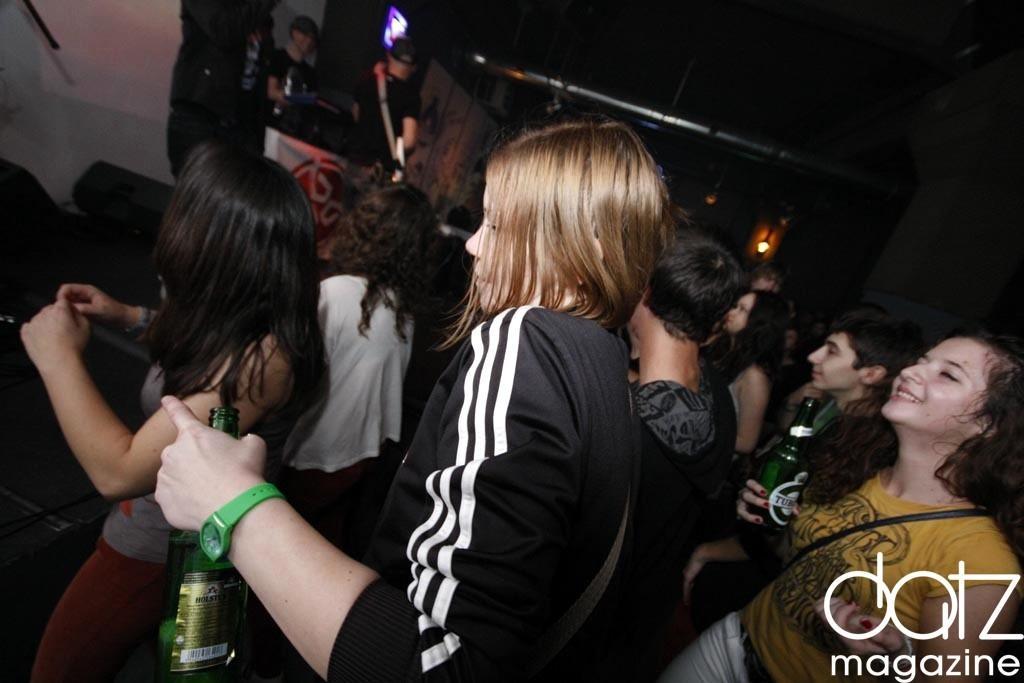Could you give a brief overview of what you see in this image? In the image we can see the group of peoples were standing and they were holding wine bottles,and they were smiling. And coming to the background were some more peoples on the stage. 